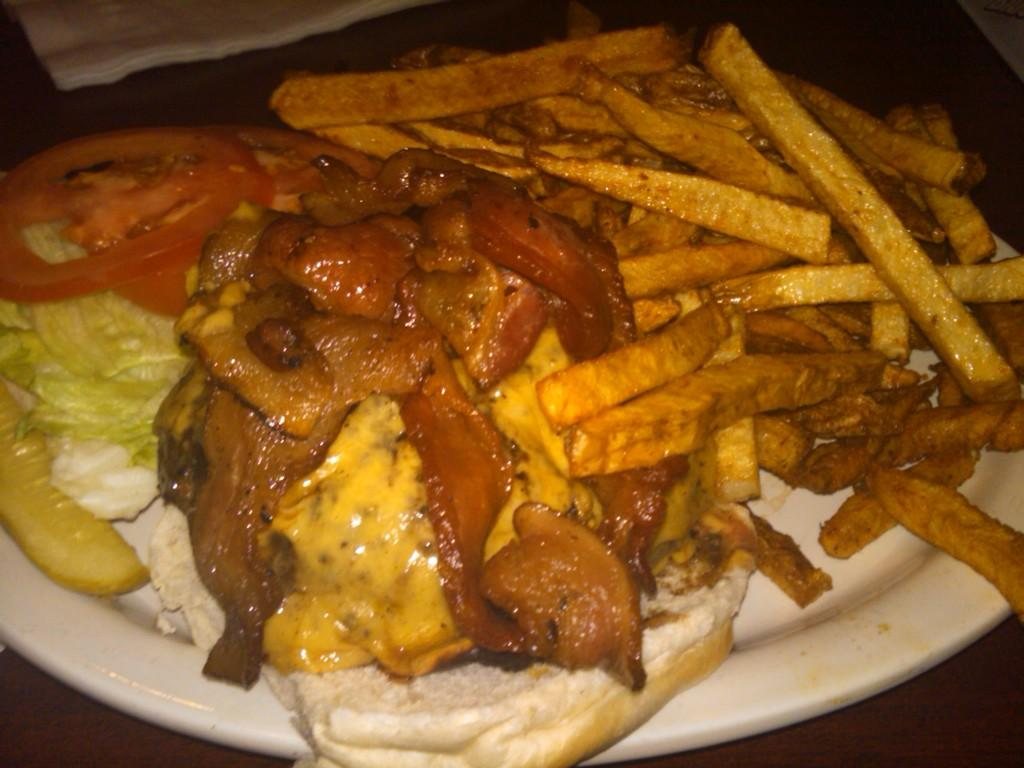What is on the plate that is visible in the image? There is a plate containing food in the image. How many giraffes can be seen in the image? There are no giraffes present in the image. What type of fan is being used to cool the food in the image? There is no fan present in the image, and the food does not require cooling. 